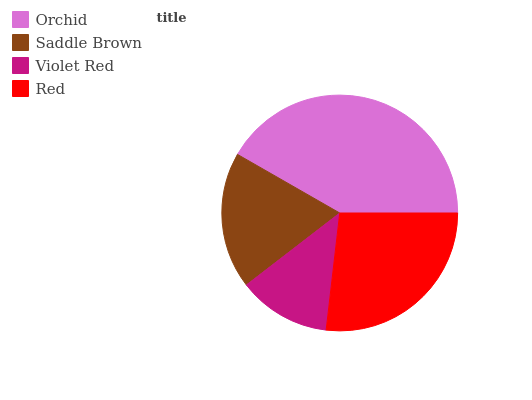Is Violet Red the minimum?
Answer yes or no. Yes. Is Orchid the maximum?
Answer yes or no. Yes. Is Saddle Brown the minimum?
Answer yes or no. No. Is Saddle Brown the maximum?
Answer yes or no. No. Is Orchid greater than Saddle Brown?
Answer yes or no. Yes. Is Saddle Brown less than Orchid?
Answer yes or no. Yes. Is Saddle Brown greater than Orchid?
Answer yes or no. No. Is Orchid less than Saddle Brown?
Answer yes or no. No. Is Red the high median?
Answer yes or no. Yes. Is Saddle Brown the low median?
Answer yes or no. Yes. Is Violet Red the high median?
Answer yes or no. No. Is Orchid the low median?
Answer yes or no. No. 